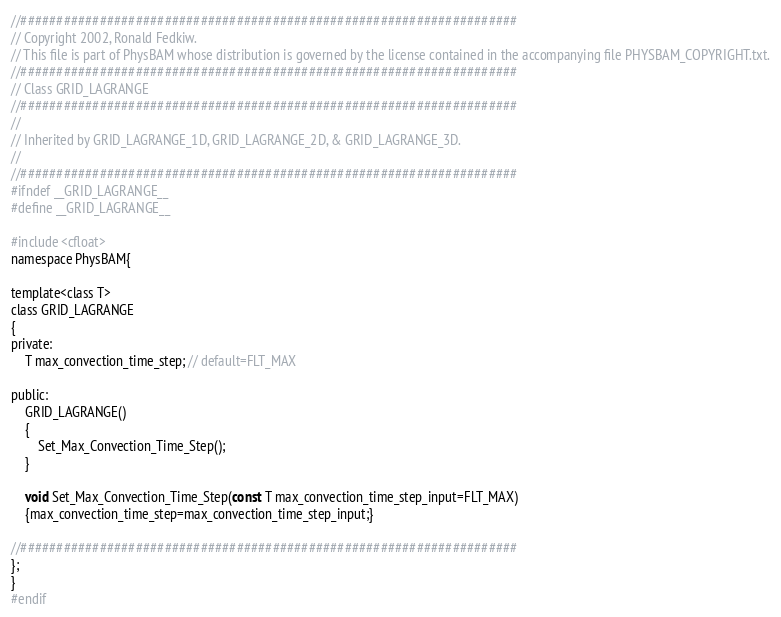Convert code to text. <code><loc_0><loc_0><loc_500><loc_500><_C_>//#####################################################################
// Copyright 2002, Ronald Fedkiw.
// This file is part of PhysBAM whose distribution is governed by the license contained in the accompanying file PHYSBAM_COPYRIGHT.txt.
//#####################################################################
// Class GRID_LAGRANGE 
//#####################################################################
//
// Inherited by GRID_LAGRANGE_1D, GRID_LAGRANGE_2D, & GRID_LAGRANGE_3D. 
//
//#####################################################################
#ifndef __GRID_LAGRANGE__
#define __GRID_LAGRANGE__

#include <cfloat>
namespace PhysBAM{

template<class T>
class GRID_LAGRANGE
{
private:
    T max_convection_time_step; // default=FLT_MAX

public:
    GRID_LAGRANGE()
    {
        Set_Max_Convection_Time_Step();
    }

    void Set_Max_Convection_Time_Step(const T max_convection_time_step_input=FLT_MAX)
    {max_convection_time_step=max_convection_time_step_input;}

//#####################################################################
};
}
#endif
</code> 